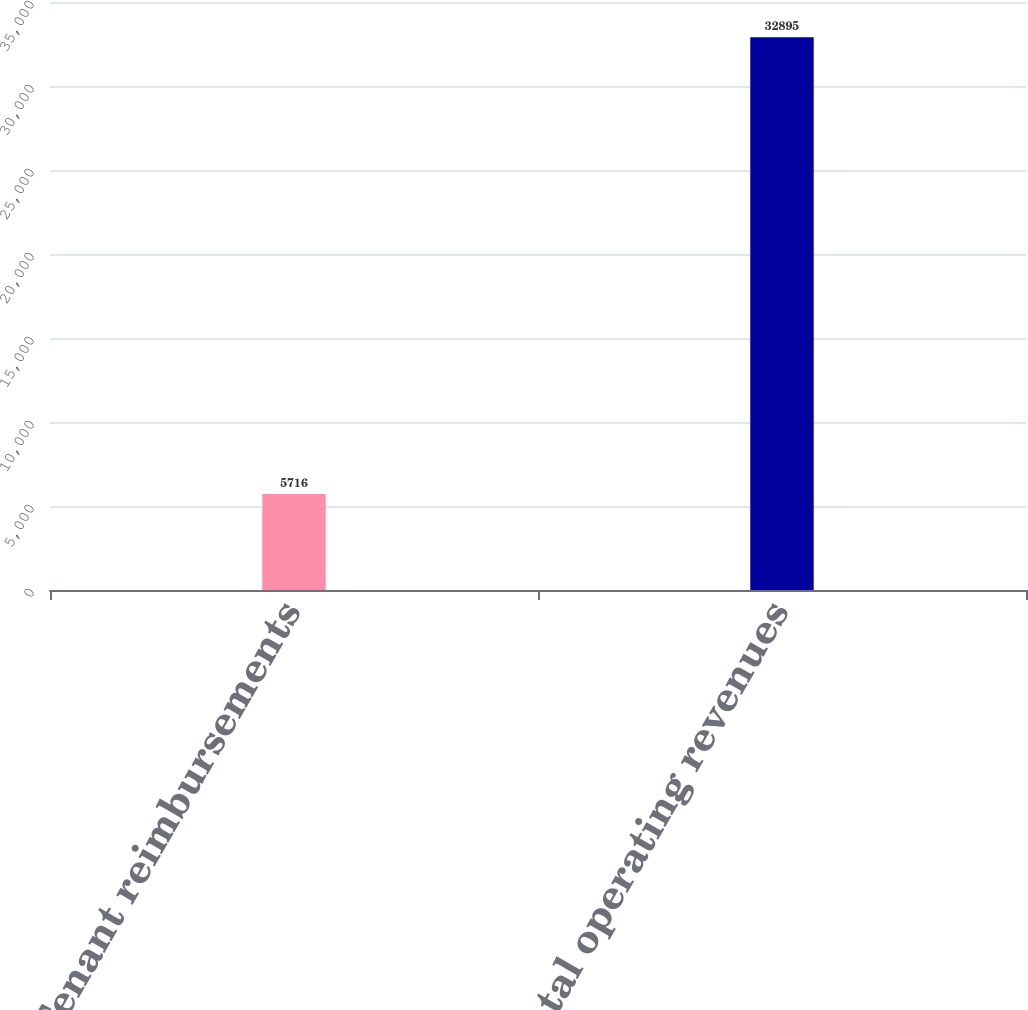<chart> <loc_0><loc_0><loc_500><loc_500><bar_chart><fcel>Tenant reimbursements<fcel>Total operating revenues<nl><fcel>5716<fcel>32895<nl></chart> 